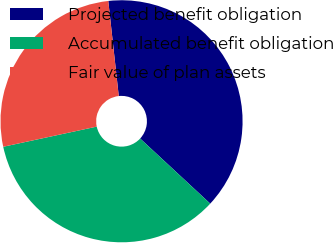Convert chart to OTSL. <chart><loc_0><loc_0><loc_500><loc_500><pie_chart><fcel>Projected benefit obligation<fcel>Accumulated benefit obligation<fcel>Fair value of plan assets<nl><fcel>38.66%<fcel>34.71%<fcel>26.63%<nl></chart> 